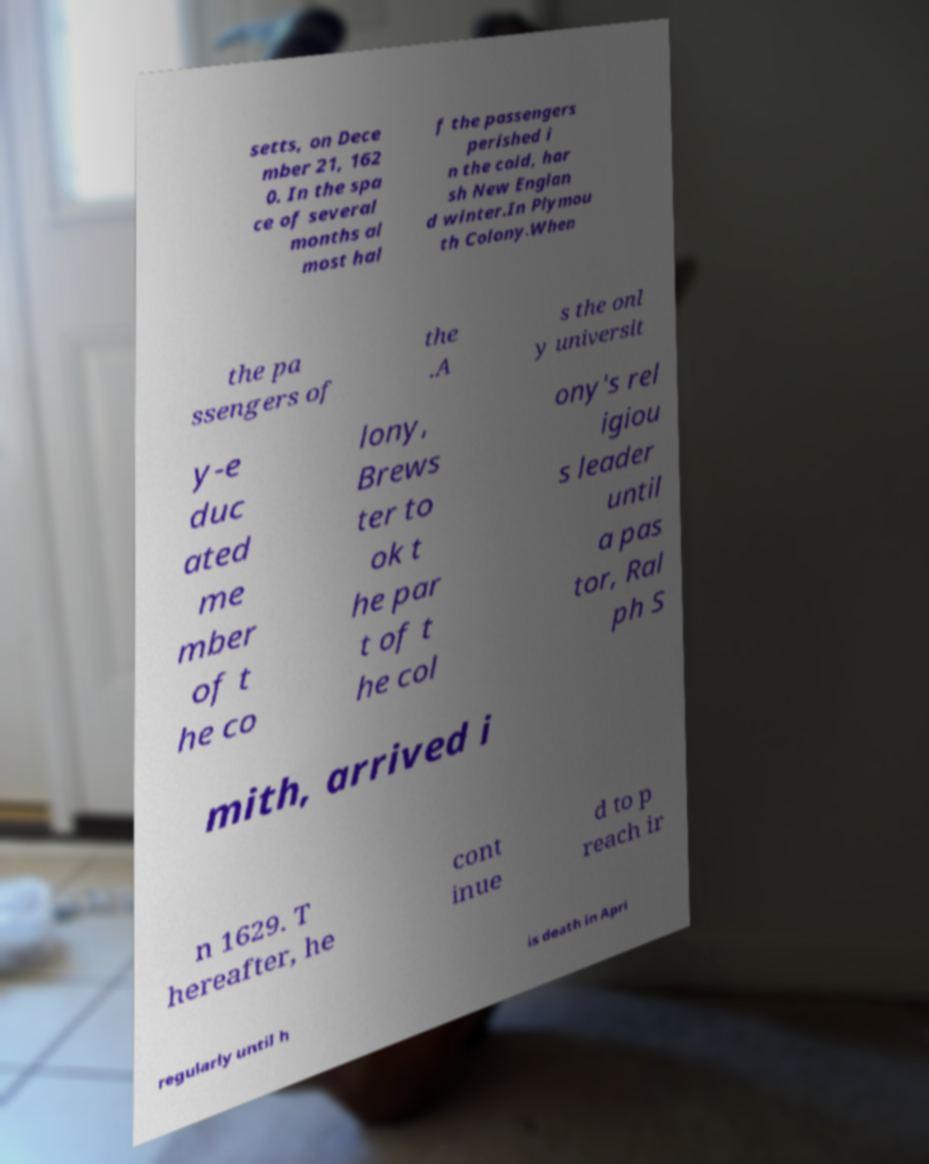What messages or text are displayed in this image? I need them in a readable, typed format. setts, on Dece mber 21, 162 0. In the spa ce of several months al most hal f the passengers perished i n the cold, har sh New Englan d winter.In Plymou th Colony.When the pa ssengers of the .A s the onl y universit y-e duc ated me mber of t he co lony, Brews ter to ok t he par t of t he col ony's rel igiou s leader until a pas tor, Ral ph S mith, arrived i n 1629. T hereafter, he cont inue d to p reach ir regularly until h is death in Apri 